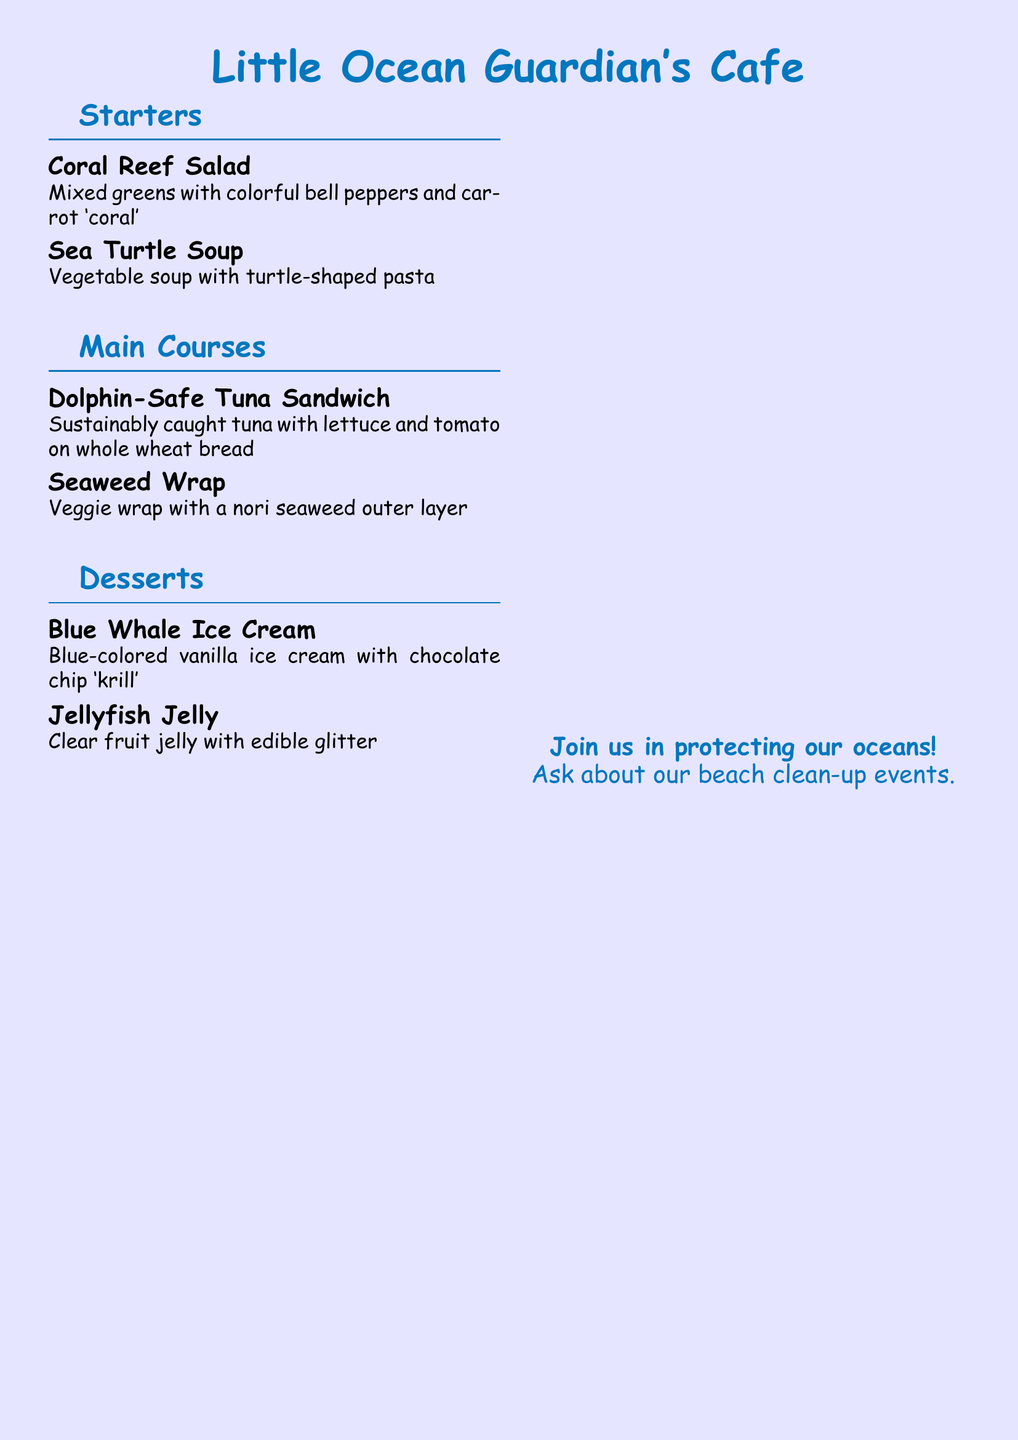What is the name of the café? The name of the café is displayed prominently at the top of the menu.
Answer: Little Ocean Guardian's Cafe What is the first starter listed? The first starter item is listed under the Starters section.
Answer: Coral Reef Salad How many sea turtle species are threatened by plastic pollution? The document states a specific number regarding sea turtle species threatened by pollution.
Answer: 6 What is the main ingredient in the Blue Whale Ice Cream? The deck specifically mentions the color and type of ice cream served as a dessert.
Answer: vanilla ice cream Which sandwich is labeled as dolphin-safe? The menu specifies which sandwich is prepared with methods that protect dolphins.
Answer: Dolphin-Safe Tuna Sandwich What is the purpose of seaweed according to the ocean facts? The ocean facts section explains the role of seaweed in relation to the environment.
Answer: absorbs CO2 What type of pasta is in the Sea Turtle Soup? The type of pasta used in the soup is shaped like an animal, as noted in the description.
Answer: turtle-shaped What color is the ocean-themed café's background? The document indicates the overall color scheme of the café's background.
Answer: blue!10 How much krill can blue whales eat in a day? The ocean facts provide a specific quantity that blue whales can consume daily.
Answer: 6 tons 